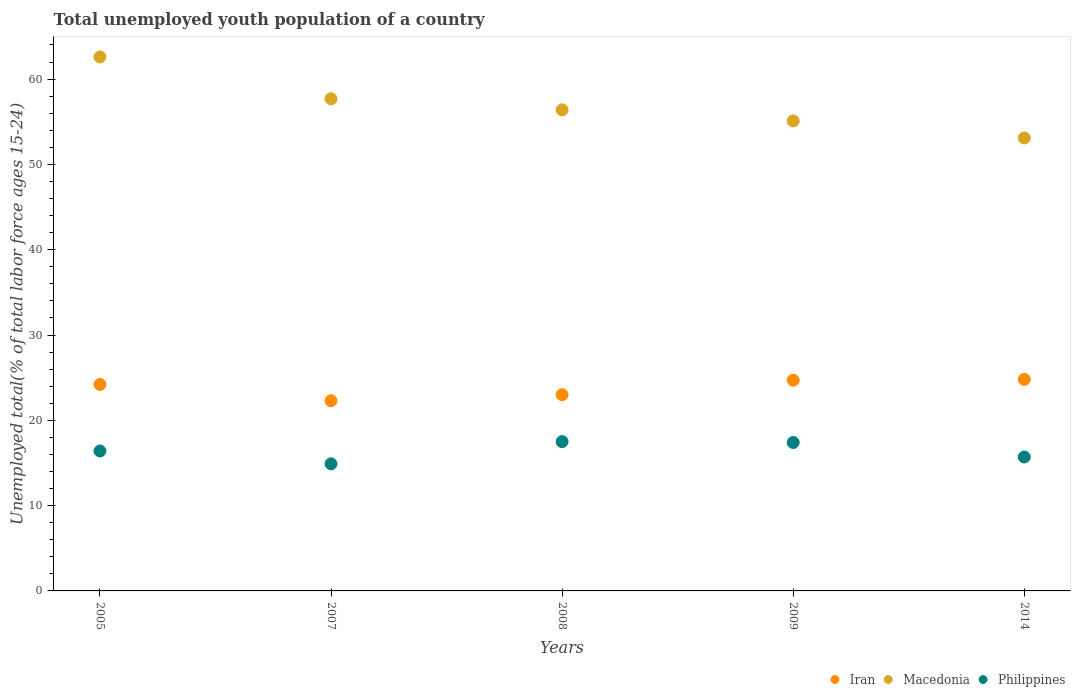Is the number of dotlines equal to the number of legend labels?
Your answer should be compact. Yes. What is the percentage of total unemployed youth population of a country in Philippines in 2009?
Your answer should be very brief. 17.4. Across all years, what is the maximum percentage of total unemployed youth population of a country in Macedonia?
Give a very brief answer. 62.6. Across all years, what is the minimum percentage of total unemployed youth population of a country in Iran?
Your answer should be very brief. 22.3. In which year was the percentage of total unemployed youth population of a country in Philippines minimum?
Keep it short and to the point. 2007. What is the total percentage of total unemployed youth population of a country in Iran in the graph?
Your response must be concise. 119. What is the difference between the percentage of total unemployed youth population of a country in Macedonia in 2007 and that in 2014?
Offer a very short reply. 4.6. What is the difference between the percentage of total unemployed youth population of a country in Macedonia in 2008 and the percentage of total unemployed youth population of a country in Philippines in 2007?
Ensure brevity in your answer.  41.5. What is the average percentage of total unemployed youth population of a country in Macedonia per year?
Provide a short and direct response. 56.98. In the year 2014, what is the difference between the percentage of total unemployed youth population of a country in Iran and percentage of total unemployed youth population of a country in Macedonia?
Make the answer very short. -28.3. In how many years, is the percentage of total unemployed youth population of a country in Macedonia greater than 62 %?
Give a very brief answer. 1. What is the ratio of the percentage of total unemployed youth population of a country in Macedonia in 2005 to that in 2014?
Provide a short and direct response. 1.18. Is the percentage of total unemployed youth population of a country in Philippines in 2009 less than that in 2014?
Offer a very short reply. No. What is the difference between the highest and the second highest percentage of total unemployed youth population of a country in Macedonia?
Make the answer very short. 4.9. What is the difference between the highest and the lowest percentage of total unemployed youth population of a country in Macedonia?
Keep it short and to the point. 9.5. Is the sum of the percentage of total unemployed youth population of a country in Iran in 2005 and 2008 greater than the maximum percentage of total unemployed youth population of a country in Macedonia across all years?
Give a very brief answer. No. Does the percentage of total unemployed youth population of a country in Iran monotonically increase over the years?
Make the answer very short. No. How many dotlines are there?
Ensure brevity in your answer.  3. What is the difference between two consecutive major ticks on the Y-axis?
Offer a terse response. 10. How are the legend labels stacked?
Your answer should be compact. Horizontal. What is the title of the graph?
Offer a very short reply. Total unemployed youth population of a country. Does "Guatemala" appear as one of the legend labels in the graph?
Offer a terse response. No. What is the label or title of the Y-axis?
Your response must be concise. Unemployed total(% of total labor force ages 15-24). What is the Unemployed total(% of total labor force ages 15-24) in Iran in 2005?
Give a very brief answer. 24.2. What is the Unemployed total(% of total labor force ages 15-24) in Macedonia in 2005?
Provide a short and direct response. 62.6. What is the Unemployed total(% of total labor force ages 15-24) in Philippines in 2005?
Give a very brief answer. 16.4. What is the Unemployed total(% of total labor force ages 15-24) of Iran in 2007?
Provide a succinct answer. 22.3. What is the Unemployed total(% of total labor force ages 15-24) in Macedonia in 2007?
Give a very brief answer. 57.7. What is the Unemployed total(% of total labor force ages 15-24) in Philippines in 2007?
Your response must be concise. 14.9. What is the Unemployed total(% of total labor force ages 15-24) in Iran in 2008?
Provide a succinct answer. 23. What is the Unemployed total(% of total labor force ages 15-24) in Macedonia in 2008?
Provide a short and direct response. 56.4. What is the Unemployed total(% of total labor force ages 15-24) of Philippines in 2008?
Keep it short and to the point. 17.5. What is the Unemployed total(% of total labor force ages 15-24) in Iran in 2009?
Your response must be concise. 24.7. What is the Unemployed total(% of total labor force ages 15-24) in Macedonia in 2009?
Offer a terse response. 55.1. What is the Unemployed total(% of total labor force ages 15-24) of Philippines in 2009?
Give a very brief answer. 17.4. What is the Unemployed total(% of total labor force ages 15-24) in Iran in 2014?
Offer a terse response. 24.8. What is the Unemployed total(% of total labor force ages 15-24) in Macedonia in 2014?
Your response must be concise. 53.1. What is the Unemployed total(% of total labor force ages 15-24) of Philippines in 2014?
Keep it short and to the point. 15.7. Across all years, what is the maximum Unemployed total(% of total labor force ages 15-24) of Iran?
Offer a terse response. 24.8. Across all years, what is the maximum Unemployed total(% of total labor force ages 15-24) in Macedonia?
Give a very brief answer. 62.6. Across all years, what is the minimum Unemployed total(% of total labor force ages 15-24) of Iran?
Ensure brevity in your answer.  22.3. Across all years, what is the minimum Unemployed total(% of total labor force ages 15-24) of Macedonia?
Provide a short and direct response. 53.1. Across all years, what is the minimum Unemployed total(% of total labor force ages 15-24) in Philippines?
Make the answer very short. 14.9. What is the total Unemployed total(% of total labor force ages 15-24) in Iran in the graph?
Keep it short and to the point. 119. What is the total Unemployed total(% of total labor force ages 15-24) in Macedonia in the graph?
Your response must be concise. 284.9. What is the total Unemployed total(% of total labor force ages 15-24) of Philippines in the graph?
Keep it short and to the point. 81.9. What is the difference between the Unemployed total(% of total labor force ages 15-24) in Macedonia in 2005 and that in 2007?
Ensure brevity in your answer.  4.9. What is the difference between the Unemployed total(% of total labor force ages 15-24) of Macedonia in 2005 and that in 2008?
Offer a terse response. 6.2. What is the difference between the Unemployed total(% of total labor force ages 15-24) of Iran in 2005 and that in 2014?
Make the answer very short. -0.6. What is the difference between the Unemployed total(% of total labor force ages 15-24) of Philippines in 2005 and that in 2014?
Provide a short and direct response. 0.7. What is the difference between the Unemployed total(% of total labor force ages 15-24) of Iran in 2007 and that in 2009?
Provide a succinct answer. -2.4. What is the difference between the Unemployed total(% of total labor force ages 15-24) of Macedonia in 2007 and that in 2009?
Keep it short and to the point. 2.6. What is the difference between the Unemployed total(% of total labor force ages 15-24) in Macedonia in 2007 and that in 2014?
Your answer should be very brief. 4.6. What is the difference between the Unemployed total(% of total labor force ages 15-24) in Iran in 2008 and that in 2009?
Make the answer very short. -1.7. What is the difference between the Unemployed total(% of total labor force ages 15-24) of Philippines in 2008 and that in 2009?
Offer a terse response. 0.1. What is the difference between the Unemployed total(% of total labor force ages 15-24) of Iran in 2008 and that in 2014?
Keep it short and to the point. -1.8. What is the difference between the Unemployed total(% of total labor force ages 15-24) in Philippines in 2008 and that in 2014?
Keep it short and to the point. 1.8. What is the difference between the Unemployed total(% of total labor force ages 15-24) of Philippines in 2009 and that in 2014?
Keep it short and to the point. 1.7. What is the difference between the Unemployed total(% of total labor force ages 15-24) of Iran in 2005 and the Unemployed total(% of total labor force ages 15-24) of Macedonia in 2007?
Keep it short and to the point. -33.5. What is the difference between the Unemployed total(% of total labor force ages 15-24) in Iran in 2005 and the Unemployed total(% of total labor force ages 15-24) in Philippines in 2007?
Your answer should be compact. 9.3. What is the difference between the Unemployed total(% of total labor force ages 15-24) in Macedonia in 2005 and the Unemployed total(% of total labor force ages 15-24) in Philippines in 2007?
Make the answer very short. 47.7. What is the difference between the Unemployed total(% of total labor force ages 15-24) of Iran in 2005 and the Unemployed total(% of total labor force ages 15-24) of Macedonia in 2008?
Keep it short and to the point. -32.2. What is the difference between the Unemployed total(% of total labor force ages 15-24) in Macedonia in 2005 and the Unemployed total(% of total labor force ages 15-24) in Philippines in 2008?
Your response must be concise. 45.1. What is the difference between the Unemployed total(% of total labor force ages 15-24) in Iran in 2005 and the Unemployed total(% of total labor force ages 15-24) in Macedonia in 2009?
Keep it short and to the point. -30.9. What is the difference between the Unemployed total(% of total labor force ages 15-24) of Iran in 2005 and the Unemployed total(% of total labor force ages 15-24) of Philippines in 2009?
Provide a succinct answer. 6.8. What is the difference between the Unemployed total(% of total labor force ages 15-24) in Macedonia in 2005 and the Unemployed total(% of total labor force ages 15-24) in Philippines in 2009?
Provide a succinct answer. 45.2. What is the difference between the Unemployed total(% of total labor force ages 15-24) in Iran in 2005 and the Unemployed total(% of total labor force ages 15-24) in Macedonia in 2014?
Your answer should be compact. -28.9. What is the difference between the Unemployed total(% of total labor force ages 15-24) in Macedonia in 2005 and the Unemployed total(% of total labor force ages 15-24) in Philippines in 2014?
Make the answer very short. 46.9. What is the difference between the Unemployed total(% of total labor force ages 15-24) of Iran in 2007 and the Unemployed total(% of total labor force ages 15-24) of Macedonia in 2008?
Make the answer very short. -34.1. What is the difference between the Unemployed total(% of total labor force ages 15-24) of Iran in 2007 and the Unemployed total(% of total labor force ages 15-24) of Philippines in 2008?
Provide a succinct answer. 4.8. What is the difference between the Unemployed total(% of total labor force ages 15-24) in Macedonia in 2007 and the Unemployed total(% of total labor force ages 15-24) in Philippines in 2008?
Keep it short and to the point. 40.2. What is the difference between the Unemployed total(% of total labor force ages 15-24) of Iran in 2007 and the Unemployed total(% of total labor force ages 15-24) of Macedonia in 2009?
Your response must be concise. -32.8. What is the difference between the Unemployed total(% of total labor force ages 15-24) in Iran in 2007 and the Unemployed total(% of total labor force ages 15-24) in Philippines in 2009?
Your response must be concise. 4.9. What is the difference between the Unemployed total(% of total labor force ages 15-24) of Macedonia in 2007 and the Unemployed total(% of total labor force ages 15-24) of Philippines in 2009?
Your answer should be very brief. 40.3. What is the difference between the Unemployed total(% of total labor force ages 15-24) in Iran in 2007 and the Unemployed total(% of total labor force ages 15-24) in Macedonia in 2014?
Offer a very short reply. -30.8. What is the difference between the Unemployed total(% of total labor force ages 15-24) of Iran in 2007 and the Unemployed total(% of total labor force ages 15-24) of Philippines in 2014?
Provide a short and direct response. 6.6. What is the difference between the Unemployed total(% of total labor force ages 15-24) in Macedonia in 2007 and the Unemployed total(% of total labor force ages 15-24) in Philippines in 2014?
Keep it short and to the point. 42. What is the difference between the Unemployed total(% of total labor force ages 15-24) in Iran in 2008 and the Unemployed total(% of total labor force ages 15-24) in Macedonia in 2009?
Your response must be concise. -32.1. What is the difference between the Unemployed total(% of total labor force ages 15-24) in Macedonia in 2008 and the Unemployed total(% of total labor force ages 15-24) in Philippines in 2009?
Keep it short and to the point. 39. What is the difference between the Unemployed total(% of total labor force ages 15-24) of Iran in 2008 and the Unemployed total(% of total labor force ages 15-24) of Macedonia in 2014?
Ensure brevity in your answer.  -30.1. What is the difference between the Unemployed total(% of total labor force ages 15-24) of Iran in 2008 and the Unemployed total(% of total labor force ages 15-24) of Philippines in 2014?
Ensure brevity in your answer.  7.3. What is the difference between the Unemployed total(% of total labor force ages 15-24) in Macedonia in 2008 and the Unemployed total(% of total labor force ages 15-24) in Philippines in 2014?
Provide a succinct answer. 40.7. What is the difference between the Unemployed total(% of total labor force ages 15-24) of Iran in 2009 and the Unemployed total(% of total labor force ages 15-24) of Macedonia in 2014?
Offer a very short reply. -28.4. What is the difference between the Unemployed total(% of total labor force ages 15-24) in Iran in 2009 and the Unemployed total(% of total labor force ages 15-24) in Philippines in 2014?
Provide a succinct answer. 9. What is the difference between the Unemployed total(% of total labor force ages 15-24) in Macedonia in 2009 and the Unemployed total(% of total labor force ages 15-24) in Philippines in 2014?
Keep it short and to the point. 39.4. What is the average Unemployed total(% of total labor force ages 15-24) in Iran per year?
Your response must be concise. 23.8. What is the average Unemployed total(% of total labor force ages 15-24) in Macedonia per year?
Make the answer very short. 56.98. What is the average Unemployed total(% of total labor force ages 15-24) of Philippines per year?
Provide a short and direct response. 16.38. In the year 2005, what is the difference between the Unemployed total(% of total labor force ages 15-24) in Iran and Unemployed total(% of total labor force ages 15-24) in Macedonia?
Give a very brief answer. -38.4. In the year 2005, what is the difference between the Unemployed total(% of total labor force ages 15-24) in Macedonia and Unemployed total(% of total labor force ages 15-24) in Philippines?
Your response must be concise. 46.2. In the year 2007, what is the difference between the Unemployed total(% of total labor force ages 15-24) of Iran and Unemployed total(% of total labor force ages 15-24) of Macedonia?
Provide a short and direct response. -35.4. In the year 2007, what is the difference between the Unemployed total(% of total labor force ages 15-24) in Iran and Unemployed total(% of total labor force ages 15-24) in Philippines?
Your response must be concise. 7.4. In the year 2007, what is the difference between the Unemployed total(% of total labor force ages 15-24) in Macedonia and Unemployed total(% of total labor force ages 15-24) in Philippines?
Your response must be concise. 42.8. In the year 2008, what is the difference between the Unemployed total(% of total labor force ages 15-24) in Iran and Unemployed total(% of total labor force ages 15-24) in Macedonia?
Give a very brief answer. -33.4. In the year 2008, what is the difference between the Unemployed total(% of total labor force ages 15-24) in Macedonia and Unemployed total(% of total labor force ages 15-24) in Philippines?
Give a very brief answer. 38.9. In the year 2009, what is the difference between the Unemployed total(% of total labor force ages 15-24) of Iran and Unemployed total(% of total labor force ages 15-24) of Macedonia?
Your answer should be very brief. -30.4. In the year 2009, what is the difference between the Unemployed total(% of total labor force ages 15-24) in Iran and Unemployed total(% of total labor force ages 15-24) in Philippines?
Offer a terse response. 7.3. In the year 2009, what is the difference between the Unemployed total(% of total labor force ages 15-24) of Macedonia and Unemployed total(% of total labor force ages 15-24) of Philippines?
Offer a very short reply. 37.7. In the year 2014, what is the difference between the Unemployed total(% of total labor force ages 15-24) in Iran and Unemployed total(% of total labor force ages 15-24) in Macedonia?
Give a very brief answer. -28.3. In the year 2014, what is the difference between the Unemployed total(% of total labor force ages 15-24) of Iran and Unemployed total(% of total labor force ages 15-24) of Philippines?
Offer a terse response. 9.1. In the year 2014, what is the difference between the Unemployed total(% of total labor force ages 15-24) in Macedonia and Unemployed total(% of total labor force ages 15-24) in Philippines?
Keep it short and to the point. 37.4. What is the ratio of the Unemployed total(% of total labor force ages 15-24) in Iran in 2005 to that in 2007?
Provide a short and direct response. 1.09. What is the ratio of the Unemployed total(% of total labor force ages 15-24) of Macedonia in 2005 to that in 2007?
Offer a terse response. 1.08. What is the ratio of the Unemployed total(% of total labor force ages 15-24) in Philippines in 2005 to that in 2007?
Offer a very short reply. 1.1. What is the ratio of the Unemployed total(% of total labor force ages 15-24) of Iran in 2005 to that in 2008?
Give a very brief answer. 1.05. What is the ratio of the Unemployed total(% of total labor force ages 15-24) in Macedonia in 2005 to that in 2008?
Keep it short and to the point. 1.11. What is the ratio of the Unemployed total(% of total labor force ages 15-24) of Philippines in 2005 to that in 2008?
Offer a very short reply. 0.94. What is the ratio of the Unemployed total(% of total labor force ages 15-24) in Iran in 2005 to that in 2009?
Keep it short and to the point. 0.98. What is the ratio of the Unemployed total(% of total labor force ages 15-24) of Macedonia in 2005 to that in 2009?
Provide a short and direct response. 1.14. What is the ratio of the Unemployed total(% of total labor force ages 15-24) of Philippines in 2005 to that in 2009?
Provide a succinct answer. 0.94. What is the ratio of the Unemployed total(% of total labor force ages 15-24) in Iran in 2005 to that in 2014?
Give a very brief answer. 0.98. What is the ratio of the Unemployed total(% of total labor force ages 15-24) of Macedonia in 2005 to that in 2014?
Keep it short and to the point. 1.18. What is the ratio of the Unemployed total(% of total labor force ages 15-24) of Philippines in 2005 to that in 2014?
Make the answer very short. 1.04. What is the ratio of the Unemployed total(% of total labor force ages 15-24) in Iran in 2007 to that in 2008?
Provide a short and direct response. 0.97. What is the ratio of the Unemployed total(% of total labor force ages 15-24) in Macedonia in 2007 to that in 2008?
Offer a very short reply. 1.02. What is the ratio of the Unemployed total(% of total labor force ages 15-24) of Philippines in 2007 to that in 2008?
Offer a very short reply. 0.85. What is the ratio of the Unemployed total(% of total labor force ages 15-24) of Iran in 2007 to that in 2009?
Give a very brief answer. 0.9. What is the ratio of the Unemployed total(% of total labor force ages 15-24) in Macedonia in 2007 to that in 2009?
Provide a short and direct response. 1.05. What is the ratio of the Unemployed total(% of total labor force ages 15-24) of Philippines in 2007 to that in 2009?
Offer a terse response. 0.86. What is the ratio of the Unemployed total(% of total labor force ages 15-24) of Iran in 2007 to that in 2014?
Give a very brief answer. 0.9. What is the ratio of the Unemployed total(% of total labor force ages 15-24) of Macedonia in 2007 to that in 2014?
Your answer should be compact. 1.09. What is the ratio of the Unemployed total(% of total labor force ages 15-24) of Philippines in 2007 to that in 2014?
Keep it short and to the point. 0.95. What is the ratio of the Unemployed total(% of total labor force ages 15-24) of Iran in 2008 to that in 2009?
Your response must be concise. 0.93. What is the ratio of the Unemployed total(% of total labor force ages 15-24) in Macedonia in 2008 to that in 2009?
Your response must be concise. 1.02. What is the ratio of the Unemployed total(% of total labor force ages 15-24) in Philippines in 2008 to that in 2009?
Ensure brevity in your answer.  1.01. What is the ratio of the Unemployed total(% of total labor force ages 15-24) of Iran in 2008 to that in 2014?
Your answer should be very brief. 0.93. What is the ratio of the Unemployed total(% of total labor force ages 15-24) in Macedonia in 2008 to that in 2014?
Ensure brevity in your answer.  1.06. What is the ratio of the Unemployed total(% of total labor force ages 15-24) of Philippines in 2008 to that in 2014?
Ensure brevity in your answer.  1.11. What is the ratio of the Unemployed total(% of total labor force ages 15-24) of Macedonia in 2009 to that in 2014?
Your answer should be compact. 1.04. What is the ratio of the Unemployed total(% of total labor force ages 15-24) in Philippines in 2009 to that in 2014?
Make the answer very short. 1.11. What is the difference between the highest and the second highest Unemployed total(% of total labor force ages 15-24) of Iran?
Provide a succinct answer. 0.1. What is the difference between the highest and the second highest Unemployed total(% of total labor force ages 15-24) of Macedonia?
Your answer should be compact. 4.9. What is the difference between the highest and the lowest Unemployed total(% of total labor force ages 15-24) in Philippines?
Offer a terse response. 2.6. 